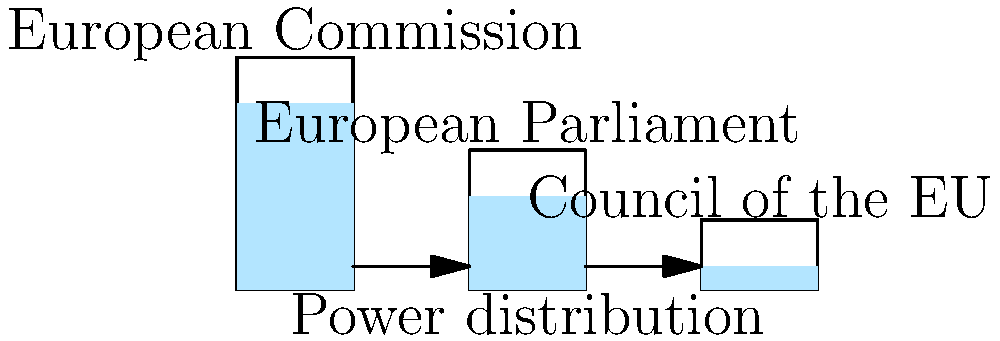In the hydraulic system shown above, which represents the distribution of power in EU institutions, how does the pressure at the bottom of each container relate to the decision-making power of the corresponding institution? Assume the liquid represents political influence. To understand the relationship between pressure in the hydraulic system and decision-making power in EU institutions, let's follow these steps:

1. In a hydraulic system, pressure is determined by the height of the liquid column. The formula for pressure is:

   $P = \rho gh$

   where $P$ is pressure, $\rho$ is density of the liquid, $g$ is gravitational acceleration, and $h$ is the height of the liquid column.

2. In our analogy:
   - The European Commission has the tallest liquid column
   - The European Parliament has a medium-height liquid column
   - The Council of the EU has the shortest liquid column

3. This implies that the pressure (analogous to decision-making power) is:
   - Highest in the European Commission
   - Medium in the European Parliament
   - Lowest in the Council of the EU

4. In reality, the European Commission indeed has significant power as it proposes and enforces legislation, implements policies, and manages the day-to-day business of the EU.

5. The European Parliament, represented by the medium-height column, has legislative, supervisory, and budgetary responsibilities, reflecting its significant but not dominant role.

6. The Council of the EU, despite its shorter column in our analogy, actually shares legislative and budgetary powers with the Parliament. This discrepancy highlights a limitation of our hydraulic analogy.

7. The connecting pipes suggest that there's a flow of power and influence between these institutions, reflecting their interdependent nature in EU governance.
Answer: Higher liquid columns represent greater decision-making power, with the European Commission having the most, followed by the Parliament, then the Council. However, this simplified model doesn't fully capture the complex power dynamics of EU institutions. 